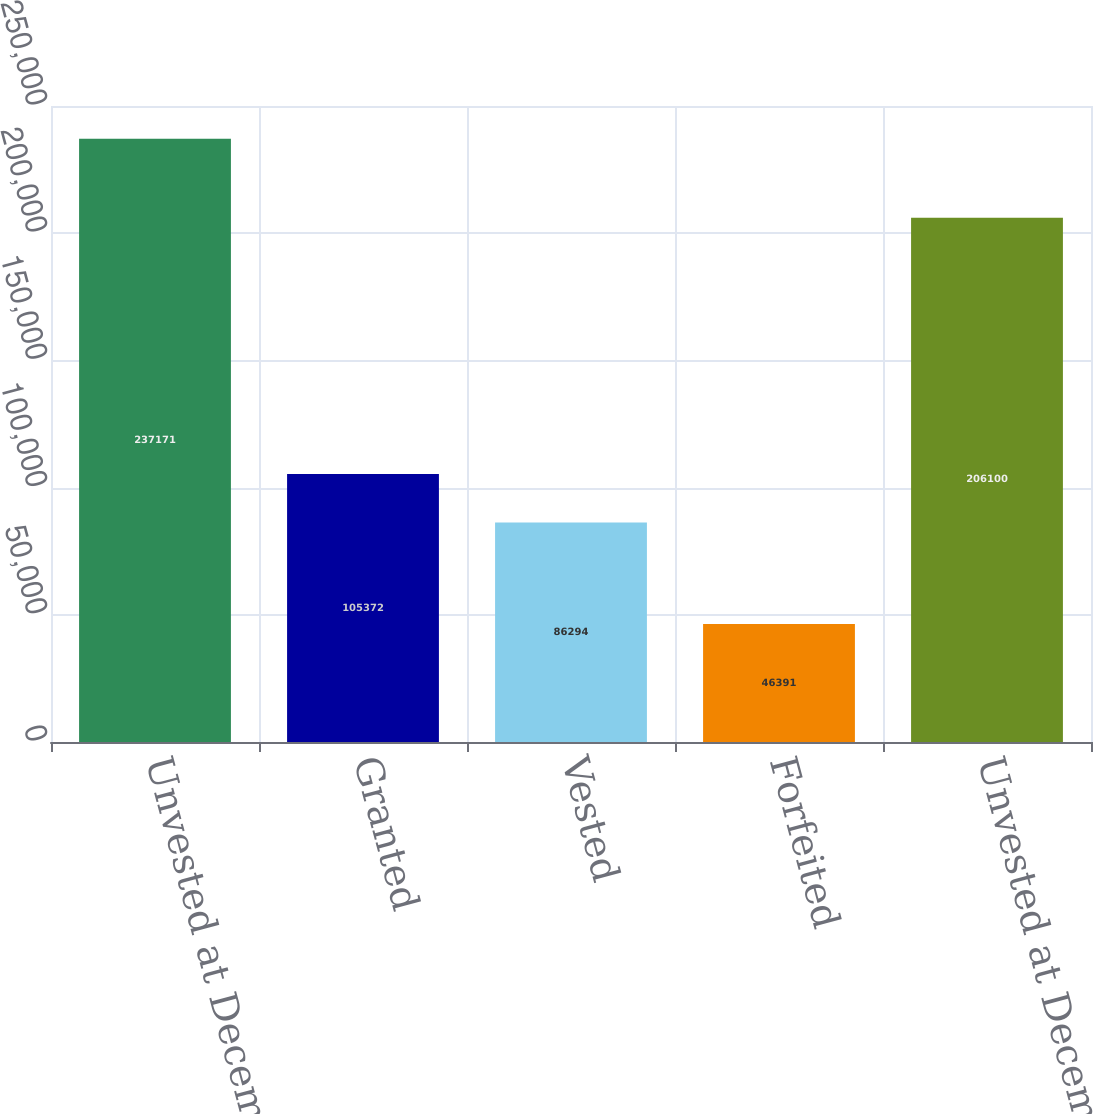Convert chart. <chart><loc_0><loc_0><loc_500><loc_500><bar_chart><fcel>Unvested at December 31 2017<fcel>Granted<fcel>Vested<fcel>Forfeited<fcel>Unvested at December 31 2018<nl><fcel>237171<fcel>105372<fcel>86294<fcel>46391<fcel>206100<nl></chart> 